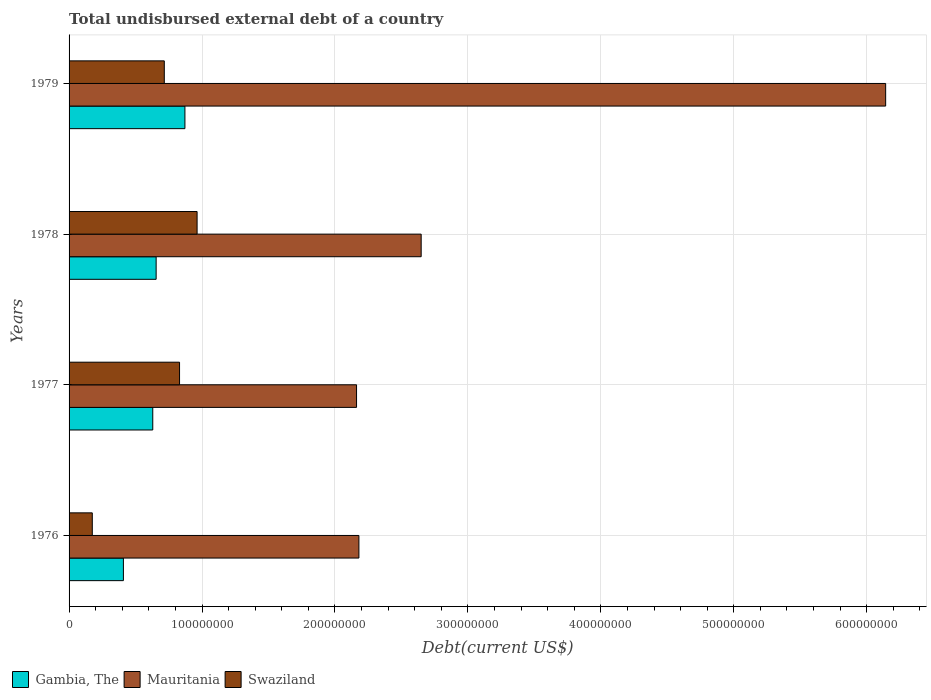Are the number of bars per tick equal to the number of legend labels?
Give a very brief answer. Yes. What is the label of the 4th group of bars from the top?
Provide a succinct answer. 1976. In how many cases, is the number of bars for a given year not equal to the number of legend labels?
Ensure brevity in your answer.  0. What is the total undisbursed external debt in Swaziland in 1978?
Offer a terse response. 9.63e+07. Across all years, what is the maximum total undisbursed external debt in Swaziland?
Your response must be concise. 9.63e+07. Across all years, what is the minimum total undisbursed external debt in Gambia, The?
Provide a succinct answer. 4.09e+07. In which year was the total undisbursed external debt in Mauritania maximum?
Keep it short and to the point. 1979. In which year was the total undisbursed external debt in Mauritania minimum?
Provide a short and direct response. 1977. What is the total total undisbursed external debt in Swaziland in the graph?
Give a very brief answer. 2.69e+08. What is the difference between the total undisbursed external debt in Mauritania in 1976 and that in 1979?
Keep it short and to the point. -3.96e+08. What is the difference between the total undisbursed external debt in Mauritania in 1978 and the total undisbursed external debt in Gambia, The in 1977?
Your answer should be compact. 2.02e+08. What is the average total undisbursed external debt in Mauritania per year?
Your answer should be compact. 3.28e+08. In the year 1977, what is the difference between the total undisbursed external debt in Swaziland and total undisbursed external debt in Mauritania?
Offer a very short reply. -1.33e+08. In how many years, is the total undisbursed external debt in Mauritania greater than 600000000 US$?
Make the answer very short. 1. What is the ratio of the total undisbursed external debt in Gambia, The in 1976 to that in 1977?
Your answer should be compact. 0.65. Is the total undisbursed external debt in Mauritania in 1978 less than that in 1979?
Offer a very short reply. Yes. What is the difference between the highest and the second highest total undisbursed external debt in Mauritania?
Give a very brief answer. 3.49e+08. What is the difference between the highest and the lowest total undisbursed external debt in Mauritania?
Keep it short and to the point. 3.98e+08. Is the sum of the total undisbursed external debt in Mauritania in 1976 and 1979 greater than the maximum total undisbursed external debt in Swaziland across all years?
Make the answer very short. Yes. What does the 2nd bar from the top in 1979 represents?
Keep it short and to the point. Mauritania. What does the 1st bar from the bottom in 1976 represents?
Your answer should be very brief. Gambia, The. Is it the case that in every year, the sum of the total undisbursed external debt in Swaziland and total undisbursed external debt in Mauritania is greater than the total undisbursed external debt in Gambia, The?
Offer a terse response. Yes. How many bars are there?
Your answer should be compact. 12. How many years are there in the graph?
Ensure brevity in your answer.  4. What is the difference between two consecutive major ticks on the X-axis?
Keep it short and to the point. 1.00e+08. Are the values on the major ticks of X-axis written in scientific E-notation?
Your answer should be compact. No. Does the graph contain grids?
Offer a very short reply. Yes. How many legend labels are there?
Offer a terse response. 3. How are the legend labels stacked?
Provide a succinct answer. Horizontal. What is the title of the graph?
Give a very brief answer. Total undisbursed external debt of a country. Does "Middle income" appear as one of the legend labels in the graph?
Provide a succinct answer. No. What is the label or title of the X-axis?
Your answer should be compact. Debt(current US$). What is the Debt(current US$) of Gambia, The in 1976?
Make the answer very short. 4.09e+07. What is the Debt(current US$) of Mauritania in 1976?
Offer a very short reply. 2.18e+08. What is the Debt(current US$) in Swaziland in 1976?
Ensure brevity in your answer.  1.75e+07. What is the Debt(current US$) of Gambia, The in 1977?
Ensure brevity in your answer.  6.30e+07. What is the Debt(current US$) of Mauritania in 1977?
Keep it short and to the point. 2.16e+08. What is the Debt(current US$) in Swaziland in 1977?
Offer a very short reply. 8.31e+07. What is the Debt(current US$) of Gambia, The in 1978?
Offer a very short reply. 6.55e+07. What is the Debt(current US$) of Mauritania in 1978?
Offer a very short reply. 2.65e+08. What is the Debt(current US$) in Swaziland in 1978?
Keep it short and to the point. 9.63e+07. What is the Debt(current US$) in Gambia, The in 1979?
Keep it short and to the point. 8.71e+07. What is the Debt(current US$) in Mauritania in 1979?
Keep it short and to the point. 6.14e+08. What is the Debt(current US$) of Swaziland in 1979?
Provide a short and direct response. 7.16e+07. Across all years, what is the maximum Debt(current US$) of Gambia, The?
Provide a succinct answer. 8.71e+07. Across all years, what is the maximum Debt(current US$) of Mauritania?
Your response must be concise. 6.14e+08. Across all years, what is the maximum Debt(current US$) of Swaziland?
Your answer should be compact. 9.63e+07. Across all years, what is the minimum Debt(current US$) in Gambia, The?
Offer a very short reply. 4.09e+07. Across all years, what is the minimum Debt(current US$) in Mauritania?
Your answer should be very brief. 2.16e+08. Across all years, what is the minimum Debt(current US$) in Swaziland?
Offer a very short reply. 1.75e+07. What is the total Debt(current US$) in Gambia, The in the graph?
Keep it short and to the point. 2.56e+08. What is the total Debt(current US$) in Mauritania in the graph?
Keep it short and to the point. 1.31e+09. What is the total Debt(current US$) in Swaziland in the graph?
Make the answer very short. 2.69e+08. What is the difference between the Debt(current US$) of Gambia, The in 1976 and that in 1977?
Provide a short and direct response. -2.21e+07. What is the difference between the Debt(current US$) in Mauritania in 1976 and that in 1977?
Make the answer very short. 1.78e+06. What is the difference between the Debt(current US$) in Swaziland in 1976 and that in 1977?
Make the answer very short. -6.56e+07. What is the difference between the Debt(current US$) of Gambia, The in 1976 and that in 1978?
Your answer should be very brief. -2.46e+07. What is the difference between the Debt(current US$) of Mauritania in 1976 and that in 1978?
Provide a succinct answer. -4.68e+07. What is the difference between the Debt(current US$) in Swaziland in 1976 and that in 1978?
Offer a very short reply. -7.88e+07. What is the difference between the Debt(current US$) of Gambia, The in 1976 and that in 1979?
Keep it short and to the point. -4.63e+07. What is the difference between the Debt(current US$) in Mauritania in 1976 and that in 1979?
Ensure brevity in your answer.  -3.96e+08. What is the difference between the Debt(current US$) of Swaziland in 1976 and that in 1979?
Offer a terse response. -5.42e+07. What is the difference between the Debt(current US$) of Gambia, The in 1977 and that in 1978?
Keep it short and to the point. -2.54e+06. What is the difference between the Debt(current US$) in Mauritania in 1977 and that in 1978?
Ensure brevity in your answer.  -4.86e+07. What is the difference between the Debt(current US$) of Swaziland in 1977 and that in 1978?
Provide a short and direct response. -1.32e+07. What is the difference between the Debt(current US$) of Gambia, The in 1977 and that in 1979?
Offer a very short reply. -2.42e+07. What is the difference between the Debt(current US$) of Mauritania in 1977 and that in 1979?
Your answer should be compact. -3.98e+08. What is the difference between the Debt(current US$) of Swaziland in 1977 and that in 1979?
Offer a very short reply. 1.15e+07. What is the difference between the Debt(current US$) in Gambia, The in 1978 and that in 1979?
Your answer should be compact. -2.16e+07. What is the difference between the Debt(current US$) in Mauritania in 1978 and that in 1979?
Ensure brevity in your answer.  -3.49e+08. What is the difference between the Debt(current US$) in Swaziland in 1978 and that in 1979?
Your answer should be compact. 2.47e+07. What is the difference between the Debt(current US$) of Gambia, The in 1976 and the Debt(current US$) of Mauritania in 1977?
Offer a terse response. -1.75e+08. What is the difference between the Debt(current US$) of Gambia, The in 1976 and the Debt(current US$) of Swaziland in 1977?
Offer a terse response. -4.22e+07. What is the difference between the Debt(current US$) in Mauritania in 1976 and the Debt(current US$) in Swaziland in 1977?
Keep it short and to the point. 1.35e+08. What is the difference between the Debt(current US$) in Gambia, The in 1976 and the Debt(current US$) in Mauritania in 1978?
Provide a short and direct response. -2.24e+08. What is the difference between the Debt(current US$) in Gambia, The in 1976 and the Debt(current US$) in Swaziland in 1978?
Your answer should be very brief. -5.54e+07. What is the difference between the Debt(current US$) of Mauritania in 1976 and the Debt(current US$) of Swaziland in 1978?
Your response must be concise. 1.22e+08. What is the difference between the Debt(current US$) of Gambia, The in 1976 and the Debt(current US$) of Mauritania in 1979?
Give a very brief answer. -5.73e+08. What is the difference between the Debt(current US$) in Gambia, The in 1976 and the Debt(current US$) in Swaziland in 1979?
Keep it short and to the point. -3.08e+07. What is the difference between the Debt(current US$) in Mauritania in 1976 and the Debt(current US$) in Swaziland in 1979?
Provide a short and direct response. 1.46e+08. What is the difference between the Debt(current US$) in Gambia, The in 1977 and the Debt(current US$) in Mauritania in 1978?
Give a very brief answer. -2.02e+08. What is the difference between the Debt(current US$) in Gambia, The in 1977 and the Debt(current US$) in Swaziland in 1978?
Ensure brevity in your answer.  -3.33e+07. What is the difference between the Debt(current US$) in Mauritania in 1977 and the Debt(current US$) in Swaziland in 1978?
Your answer should be compact. 1.20e+08. What is the difference between the Debt(current US$) in Gambia, The in 1977 and the Debt(current US$) in Mauritania in 1979?
Provide a short and direct response. -5.51e+08. What is the difference between the Debt(current US$) in Gambia, The in 1977 and the Debt(current US$) in Swaziland in 1979?
Your response must be concise. -8.67e+06. What is the difference between the Debt(current US$) in Mauritania in 1977 and the Debt(current US$) in Swaziland in 1979?
Offer a very short reply. 1.45e+08. What is the difference between the Debt(current US$) of Gambia, The in 1978 and the Debt(current US$) of Mauritania in 1979?
Your answer should be very brief. -5.49e+08. What is the difference between the Debt(current US$) in Gambia, The in 1978 and the Debt(current US$) in Swaziland in 1979?
Give a very brief answer. -6.13e+06. What is the difference between the Debt(current US$) in Mauritania in 1978 and the Debt(current US$) in Swaziland in 1979?
Offer a terse response. 1.93e+08. What is the average Debt(current US$) in Gambia, The per year?
Your answer should be compact. 6.41e+07. What is the average Debt(current US$) of Mauritania per year?
Keep it short and to the point. 3.28e+08. What is the average Debt(current US$) in Swaziland per year?
Make the answer very short. 6.71e+07. In the year 1976, what is the difference between the Debt(current US$) of Gambia, The and Debt(current US$) of Mauritania?
Ensure brevity in your answer.  -1.77e+08. In the year 1976, what is the difference between the Debt(current US$) of Gambia, The and Debt(current US$) of Swaziland?
Offer a very short reply. 2.34e+07. In the year 1976, what is the difference between the Debt(current US$) in Mauritania and Debt(current US$) in Swaziland?
Make the answer very short. 2.01e+08. In the year 1977, what is the difference between the Debt(current US$) in Gambia, The and Debt(current US$) in Mauritania?
Ensure brevity in your answer.  -1.53e+08. In the year 1977, what is the difference between the Debt(current US$) of Gambia, The and Debt(current US$) of Swaziland?
Keep it short and to the point. -2.01e+07. In the year 1977, what is the difference between the Debt(current US$) of Mauritania and Debt(current US$) of Swaziland?
Provide a short and direct response. 1.33e+08. In the year 1978, what is the difference between the Debt(current US$) in Gambia, The and Debt(current US$) in Mauritania?
Ensure brevity in your answer.  -1.99e+08. In the year 1978, what is the difference between the Debt(current US$) of Gambia, The and Debt(current US$) of Swaziland?
Provide a short and direct response. -3.08e+07. In the year 1978, what is the difference between the Debt(current US$) of Mauritania and Debt(current US$) of Swaziland?
Provide a succinct answer. 1.69e+08. In the year 1979, what is the difference between the Debt(current US$) of Gambia, The and Debt(current US$) of Mauritania?
Provide a succinct answer. -5.27e+08. In the year 1979, what is the difference between the Debt(current US$) of Gambia, The and Debt(current US$) of Swaziland?
Offer a very short reply. 1.55e+07. In the year 1979, what is the difference between the Debt(current US$) of Mauritania and Debt(current US$) of Swaziland?
Offer a terse response. 5.43e+08. What is the ratio of the Debt(current US$) of Gambia, The in 1976 to that in 1977?
Offer a terse response. 0.65. What is the ratio of the Debt(current US$) in Mauritania in 1976 to that in 1977?
Make the answer very short. 1.01. What is the ratio of the Debt(current US$) in Swaziland in 1976 to that in 1977?
Provide a succinct answer. 0.21. What is the ratio of the Debt(current US$) of Gambia, The in 1976 to that in 1978?
Give a very brief answer. 0.62. What is the ratio of the Debt(current US$) of Mauritania in 1976 to that in 1978?
Make the answer very short. 0.82. What is the ratio of the Debt(current US$) of Swaziland in 1976 to that in 1978?
Provide a short and direct response. 0.18. What is the ratio of the Debt(current US$) in Gambia, The in 1976 to that in 1979?
Make the answer very short. 0.47. What is the ratio of the Debt(current US$) of Mauritania in 1976 to that in 1979?
Offer a terse response. 0.35. What is the ratio of the Debt(current US$) of Swaziland in 1976 to that in 1979?
Give a very brief answer. 0.24. What is the ratio of the Debt(current US$) of Gambia, The in 1977 to that in 1978?
Give a very brief answer. 0.96. What is the ratio of the Debt(current US$) in Mauritania in 1977 to that in 1978?
Ensure brevity in your answer.  0.82. What is the ratio of the Debt(current US$) of Swaziland in 1977 to that in 1978?
Your answer should be compact. 0.86. What is the ratio of the Debt(current US$) of Gambia, The in 1977 to that in 1979?
Keep it short and to the point. 0.72. What is the ratio of the Debt(current US$) of Mauritania in 1977 to that in 1979?
Make the answer very short. 0.35. What is the ratio of the Debt(current US$) in Swaziland in 1977 to that in 1979?
Provide a succinct answer. 1.16. What is the ratio of the Debt(current US$) of Gambia, The in 1978 to that in 1979?
Your response must be concise. 0.75. What is the ratio of the Debt(current US$) in Mauritania in 1978 to that in 1979?
Offer a terse response. 0.43. What is the ratio of the Debt(current US$) of Swaziland in 1978 to that in 1979?
Provide a succinct answer. 1.34. What is the difference between the highest and the second highest Debt(current US$) in Gambia, The?
Offer a very short reply. 2.16e+07. What is the difference between the highest and the second highest Debt(current US$) of Mauritania?
Provide a short and direct response. 3.49e+08. What is the difference between the highest and the second highest Debt(current US$) of Swaziland?
Your answer should be very brief. 1.32e+07. What is the difference between the highest and the lowest Debt(current US$) in Gambia, The?
Provide a succinct answer. 4.63e+07. What is the difference between the highest and the lowest Debt(current US$) of Mauritania?
Provide a succinct answer. 3.98e+08. What is the difference between the highest and the lowest Debt(current US$) of Swaziland?
Provide a short and direct response. 7.88e+07. 